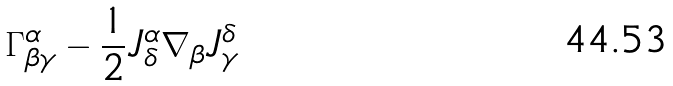<formula> <loc_0><loc_0><loc_500><loc_500>\Gamma _ { \beta \gamma } ^ { \alpha } - \frac { 1 } { 2 } J _ { \delta } ^ { \alpha } \nabla _ { \beta } J _ { \gamma } ^ { \delta }</formula> 